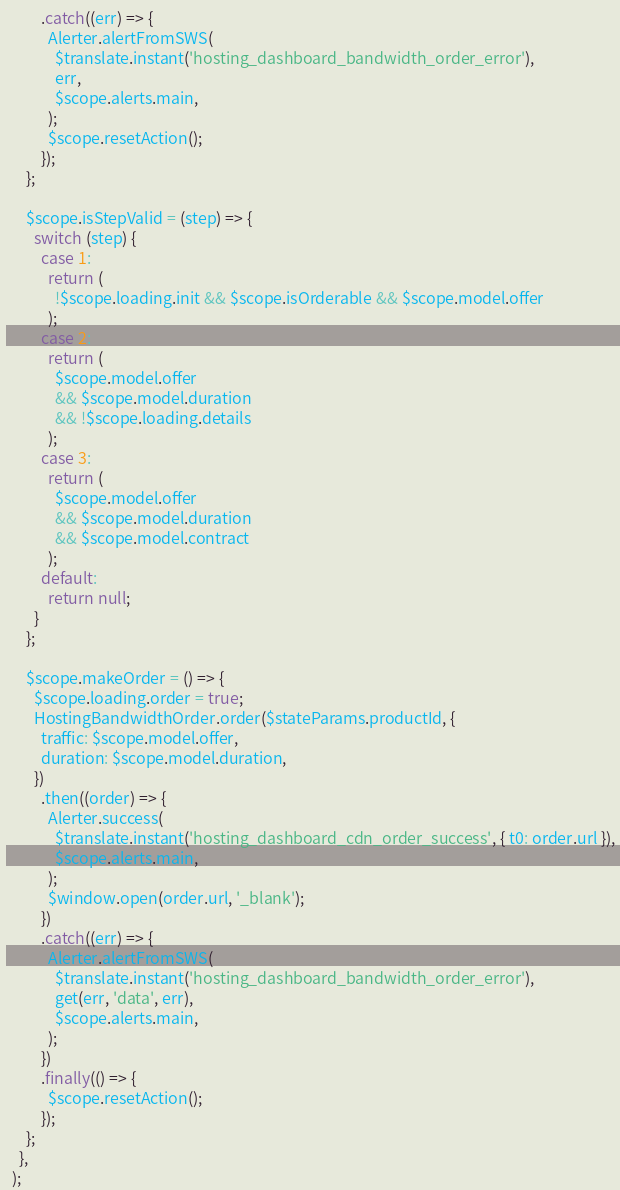Convert code to text. <code><loc_0><loc_0><loc_500><loc_500><_JavaScript_>          .catch((err) => {
            Alerter.alertFromSWS(
              $translate.instant('hosting_dashboard_bandwidth_order_error'),
              err,
              $scope.alerts.main,
            );
            $scope.resetAction();
          });
      };

      $scope.isStepValid = (step) => {
        switch (step) {
          case 1:
            return (
              !$scope.loading.init && $scope.isOrderable && $scope.model.offer
            );
          case 2:
            return (
              $scope.model.offer
              && $scope.model.duration
              && !$scope.loading.details
            );
          case 3:
            return (
              $scope.model.offer
              && $scope.model.duration
              && $scope.model.contract
            );
          default:
            return null;
        }
      };

      $scope.makeOrder = () => {
        $scope.loading.order = true;
        HostingBandwidthOrder.order($stateParams.productId, {
          traffic: $scope.model.offer,
          duration: $scope.model.duration,
        })
          .then((order) => {
            Alerter.success(
              $translate.instant('hosting_dashboard_cdn_order_success', { t0: order.url }),
              $scope.alerts.main,
            );
            $window.open(order.url, '_blank');
          })
          .catch((err) => {
            Alerter.alertFromSWS(
              $translate.instant('hosting_dashboard_bandwidth_order_error'),
              get(err, 'data', err),
              $scope.alerts.main,
            );
          })
          .finally(() => {
            $scope.resetAction();
          });
      };
    },
  );
</code> 